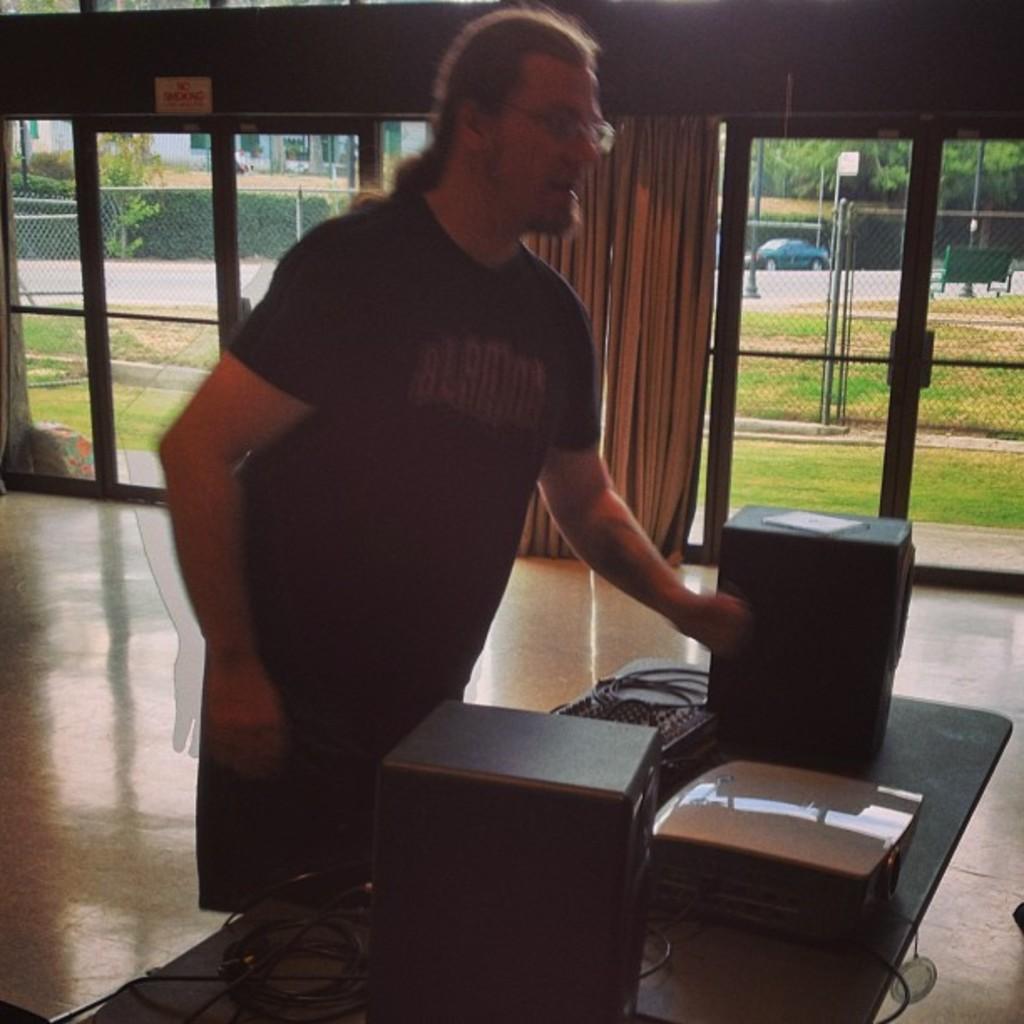Describe this image in one or two sentences. A man is standing is wearing a black t-shirt. In front of him there is a table. On the table there are two speakers and one projector. We can see a door, curtain. Outside the door there is a grass. And we can also see a car. 